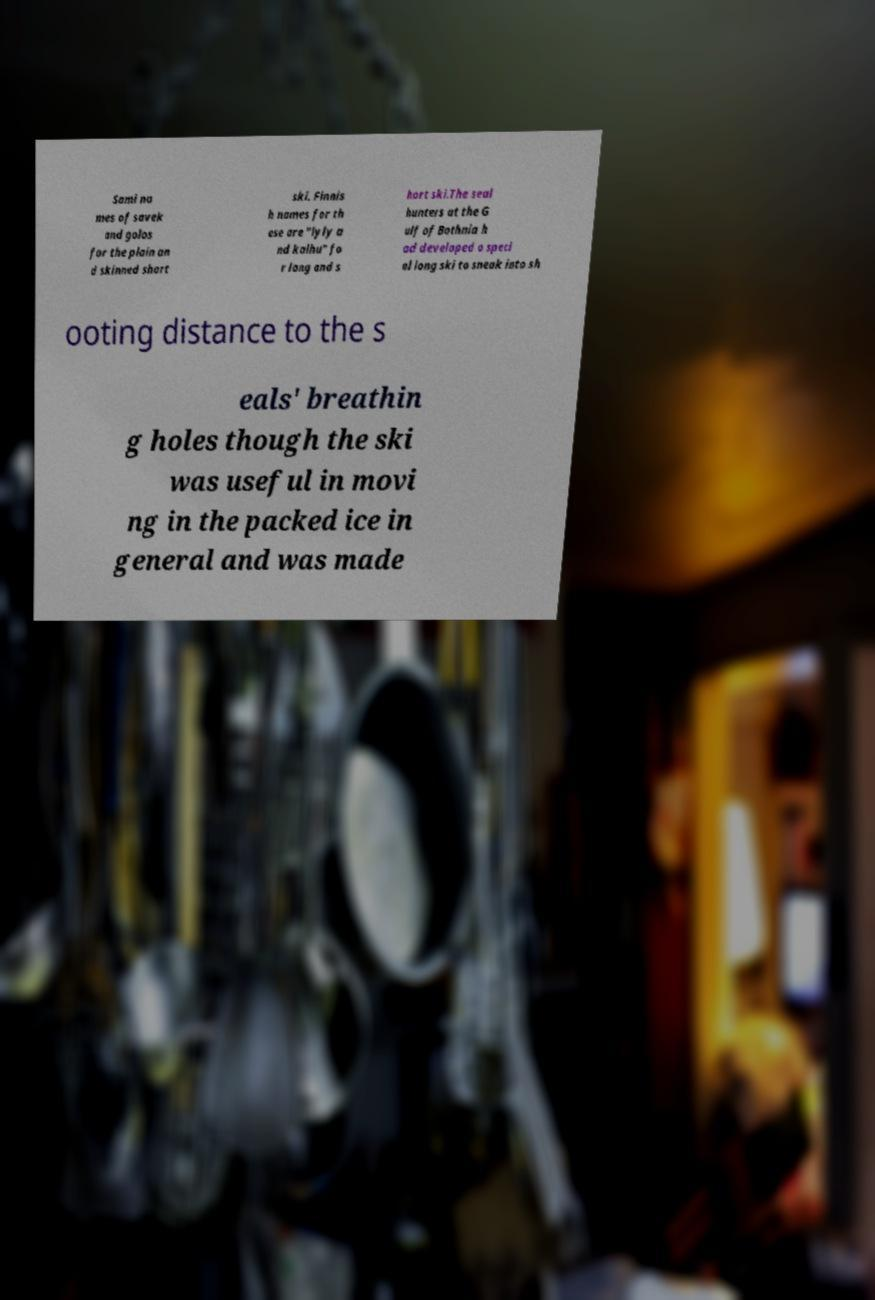I need the written content from this picture converted into text. Can you do that? Sami na mes of savek and golos for the plain an d skinned short ski. Finnis h names for th ese are "lyly a nd kalhu" fo r long and s hort ski.The seal hunters at the G ulf of Bothnia h ad developed a speci al long ski to sneak into sh ooting distance to the s eals' breathin g holes though the ski was useful in movi ng in the packed ice in general and was made 